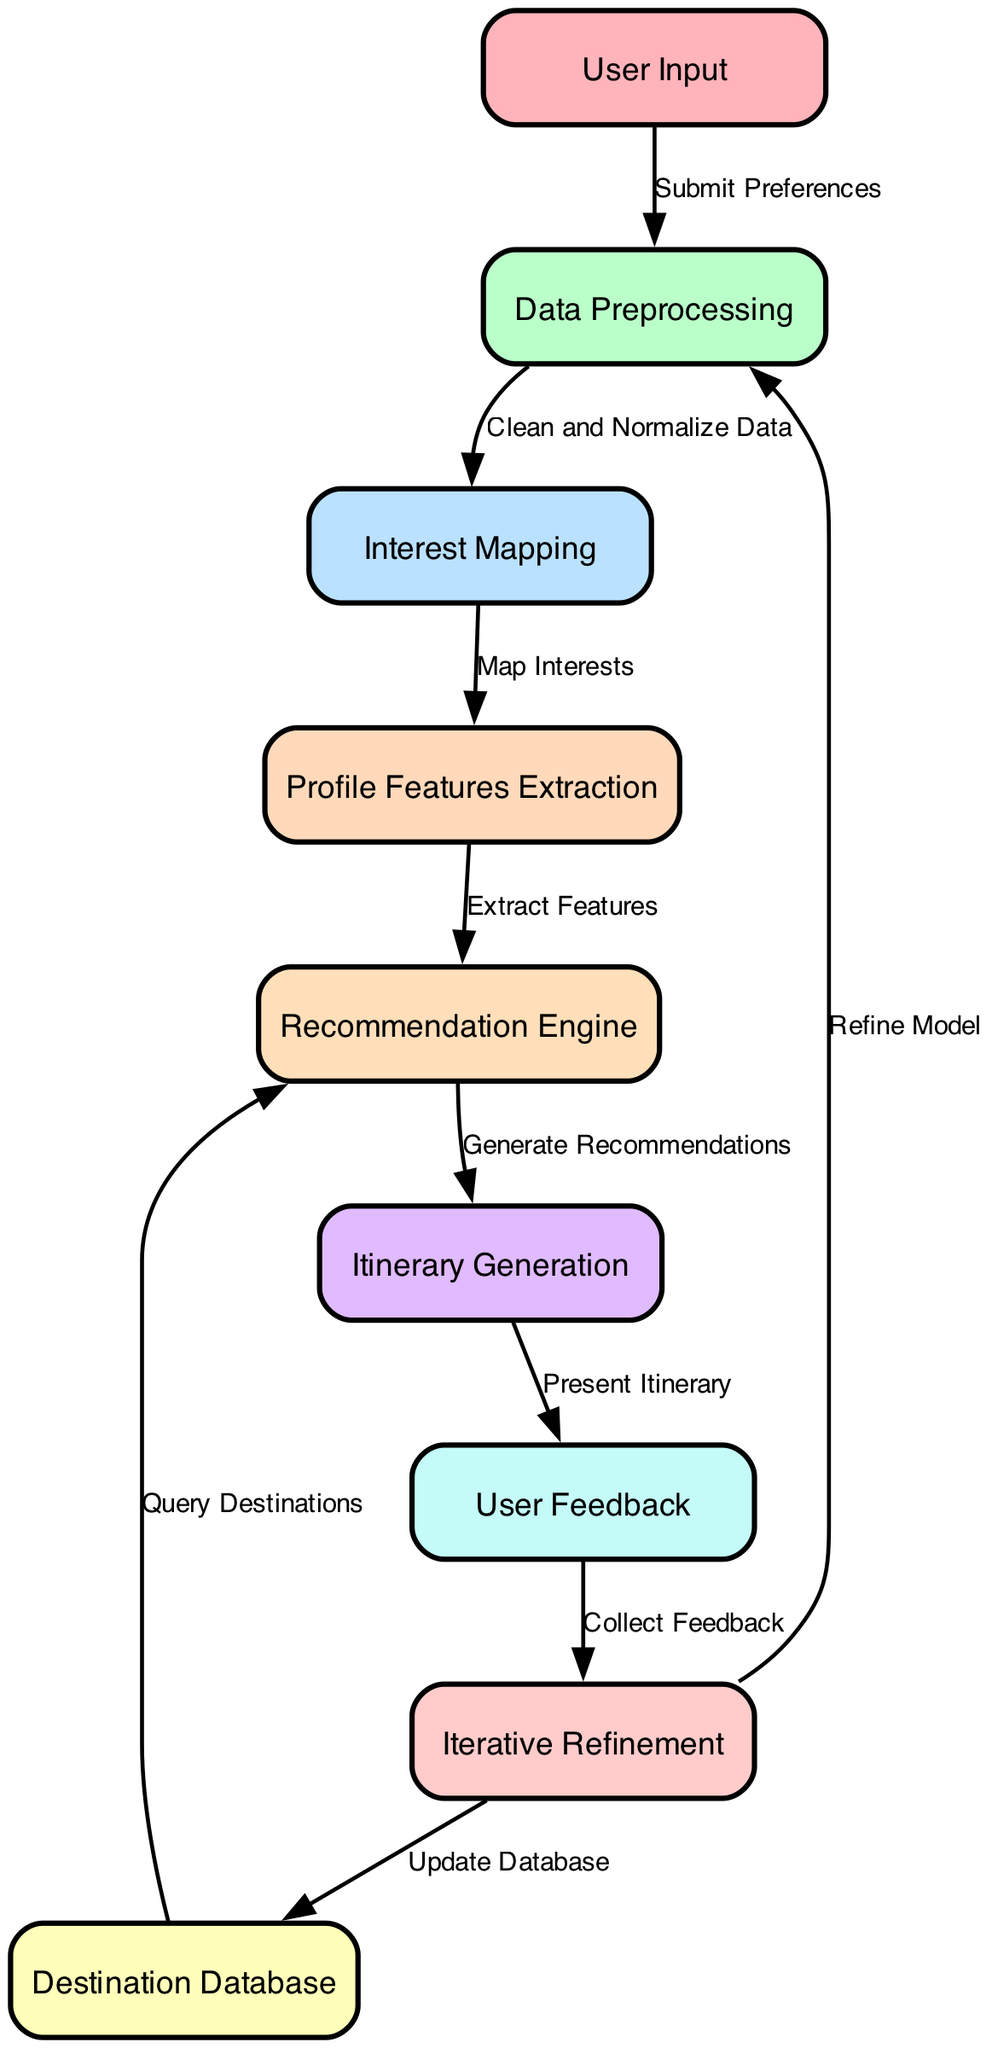What is the starting node in the diagram? The starting point of the workflow is represented by the "User Input" node. It is the first node from which all processing flows.
Answer: User Input How many nodes are present in the diagram? By counting all the unique entities in the diagram, we find that there are a total of nine nodes, each representing different stages of the itinerary planning process.
Answer: Nine Which node comes after "Data Preprocessing"? Following "Data Preprocessing," the next node in the sequence is "Interest Mapping," indicating the flow of information from preprocessing to mapping user interests.
Answer: Interest Mapping What is the relationship between "Recommendation Engine" and "Itinerary Generation"? The "Recommendation Engine" generates recommendations that directly lead to the "Itinerary Generation" node, which utilizes those recommendations to create the final itinerary for the user.
Answer: Generate Recommendations What feedback mechanism is present in the diagram? The diagram includes a feedback loop where "User Feedback" is collected and subsequently feeds into "Iterative Refinement," indicating a process of improving the recommendations based on user input.
Answer: User Feedback How does the system update its database? The database is updated through the process represented by the "Iterative Refinement" node, which branches to "Destination Database," signifying that feedback can lead to adjustments in the data stored about destinations.
Answer: Update Database What is the purpose of "Profile Features Extraction"? "Profile Features Extraction" serves as a crucial step where user interests are converted into identifiable features that can be utilized by the recommendation engine for better itinerary suggestions.
Answer: Extract Features After it presents the itinerary, what is the next step in the diagram? Following the presentation of the itinerary to the user, the next step is "User Feedback," where the system seeks impressions or opinions from the user to refine future recommendations.
Answer: User Feedback What is the end result of the recommendation engine's output? The output from the recommendation engine ultimately feeds into "Itinerary Generation," which means the final outcome of the engine's work is the generation of a personalized travel itinerary.
Answer: Itinerary Generation 